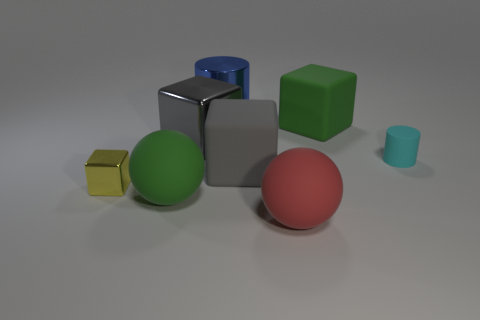There is a metallic thing behind the big green thing behind the cyan thing; is there a green matte sphere that is behind it?
Ensure brevity in your answer.  No. How many other things are there of the same material as the big blue thing?
Offer a very short reply. 2. What number of small metal things are there?
Your answer should be compact. 1. How many objects are either red objects or big objects that are to the right of the big green rubber ball?
Keep it short and to the point. 5. Are there any other things that have the same shape as the big blue shiny object?
Offer a very short reply. Yes. There is a green rubber thing that is on the right side of the red matte sphere; does it have the same size as the tiny cyan rubber cylinder?
Give a very brief answer. No. How many matte things are either green spheres or cyan cylinders?
Provide a succinct answer. 2. There is a cyan cylinder that is in front of the blue metal thing; how big is it?
Your answer should be compact. Small. Does the cyan object have the same shape as the small yellow metal thing?
Provide a short and direct response. No. How many tiny things are shiny things or yellow blocks?
Your answer should be compact. 1. 